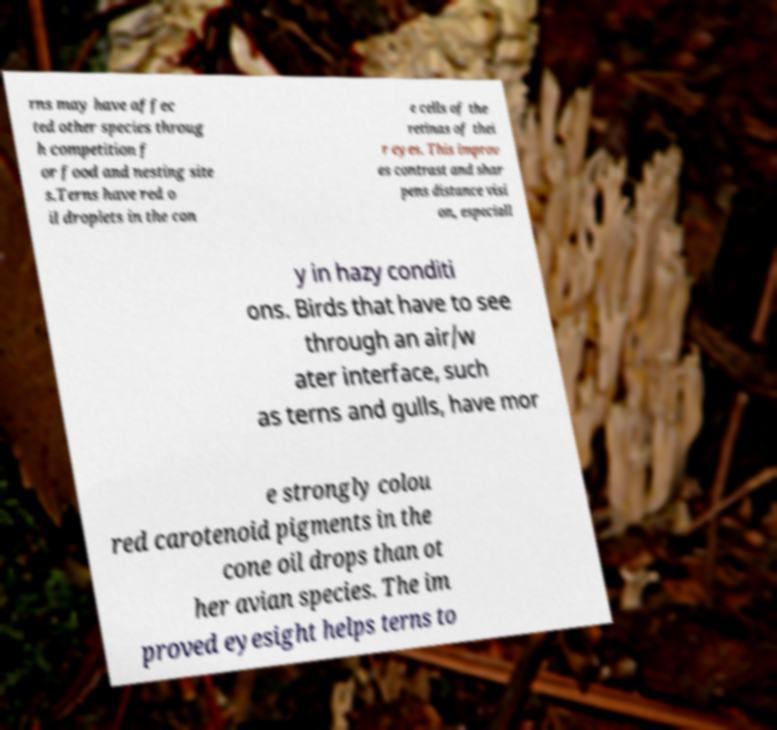Please identify and transcribe the text found in this image. rns may have affec ted other species throug h competition f or food and nesting site s.Terns have red o il droplets in the con e cells of the retinas of thei r eyes. This improv es contrast and shar pens distance visi on, especiall y in hazy conditi ons. Birds that have to see through an air/w ater interface, such as terns and gulls, have mor e strongly colou red carotenoid pigments in the cone oil drops than ot her avian species. The im proved eyesight helps terns to 